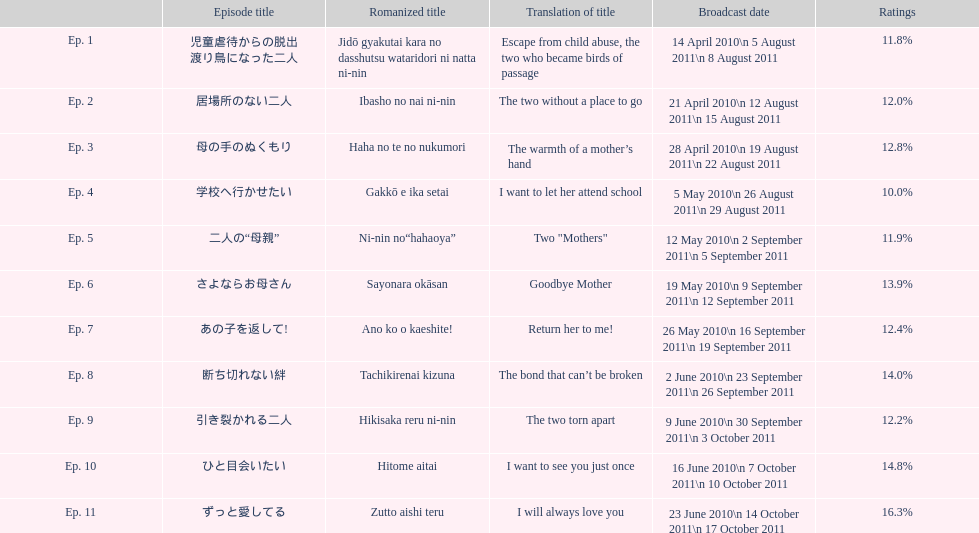Excluding the 10th episode, which alternate episode possesses a 14% rating? Ep. 8. 